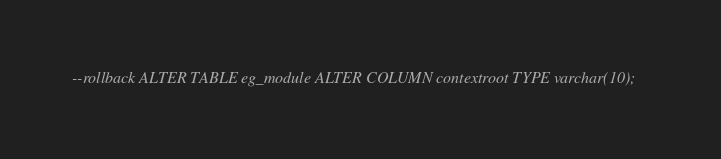Convert code to text. <code><loc_0><loc_0><loc_500><loc_500><_SQL_>--rollback ALTER TABLE eg_module ALTER COLUMN contextroot TYPE varchar(10);
</code> 